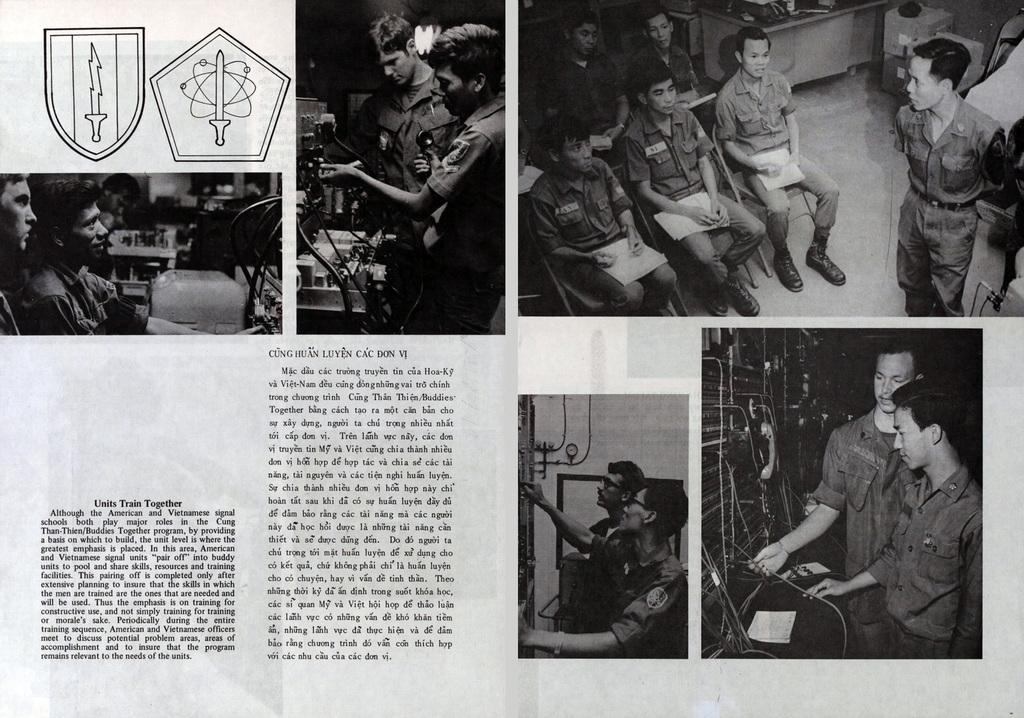What is the main subject of the page in the image? The page contains pictures and text. What types of activities are the people depicted in the pictures doing? Some of the pictures depict people working, while others show people sitting on chairs. Reasoning: Let's think step by step to produce the conversation. We start by identifying the main subject of the image, which is a page with pictures and text. Then, we describe the content of the pictures, focusing on the activities of the people depicted. We ensure that each question can be answered definitively with the information given and avoid yes/no questions. Absurd Question/Answer: How many pockets are visible on the people in the image? There are no pockets visible on the people in the image, as the focus is on their activities and not their clothing. Is there a water fountain in the image? There is no mention of a water fountain in the provided facts, and it is not visible in the image. --- Facts: 1. There is a person holding a book in the image. 2. The book has a blue cover. 3. The person is sitting on a bench. 4. There is a tree in the background of the image. Absurd Topics: parrot, sand, dance Conversation: What is the person in the image holding? The person is holding a book in the image. What color is the book's cover? The book has a blue cover. Where is the person sitting? The person is sitting on a bench. What can be seen in the background of the image? There is a tree in the background of the image. Reasoning: Let's think step by step in order to produce the conversation. We start by identifying the main subject of the image, which is the person holding a book. Then, we describe the book's cover color and the person's location, which is on a bench. Finally, we mention the background of the image, which includes a tree. Each question is designed to elicit a specific detail about the image that is known from the provided facts. Absurd Question/Answer 